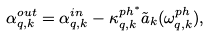<formula> <loc_0><loc_0><loc_500><loc_500>\alpha ^ { o u t } _ { { q } , { k } } = \alpha ^ { i n } _ { { q } , { k } } - \kappa ^ { p h ^ { * } } _ { { q } , { k } } \tilde { a } _ { k } ( \omega ^ { p h } _ { { q } , { k } } ) ,</formula> 